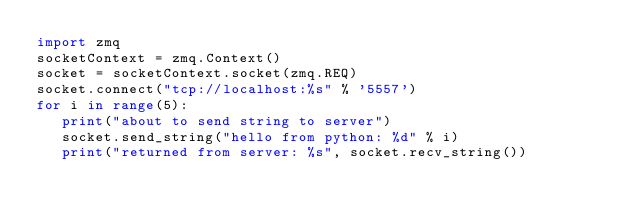<code> <loc_0><loc_0><loc_500><loc_500><_Python_>import zmq
socketContext = zmq.Context()
socket = socketContext.socket(zmq.REQ)
socket.connect("tcp://localhost:%s" % '5557')
for i in range(5):
   print("about to send string to server")
   socket.send_string("hello from python: %d" % i)
   print("returned from server: %s", socket.recv_string())
</code> 